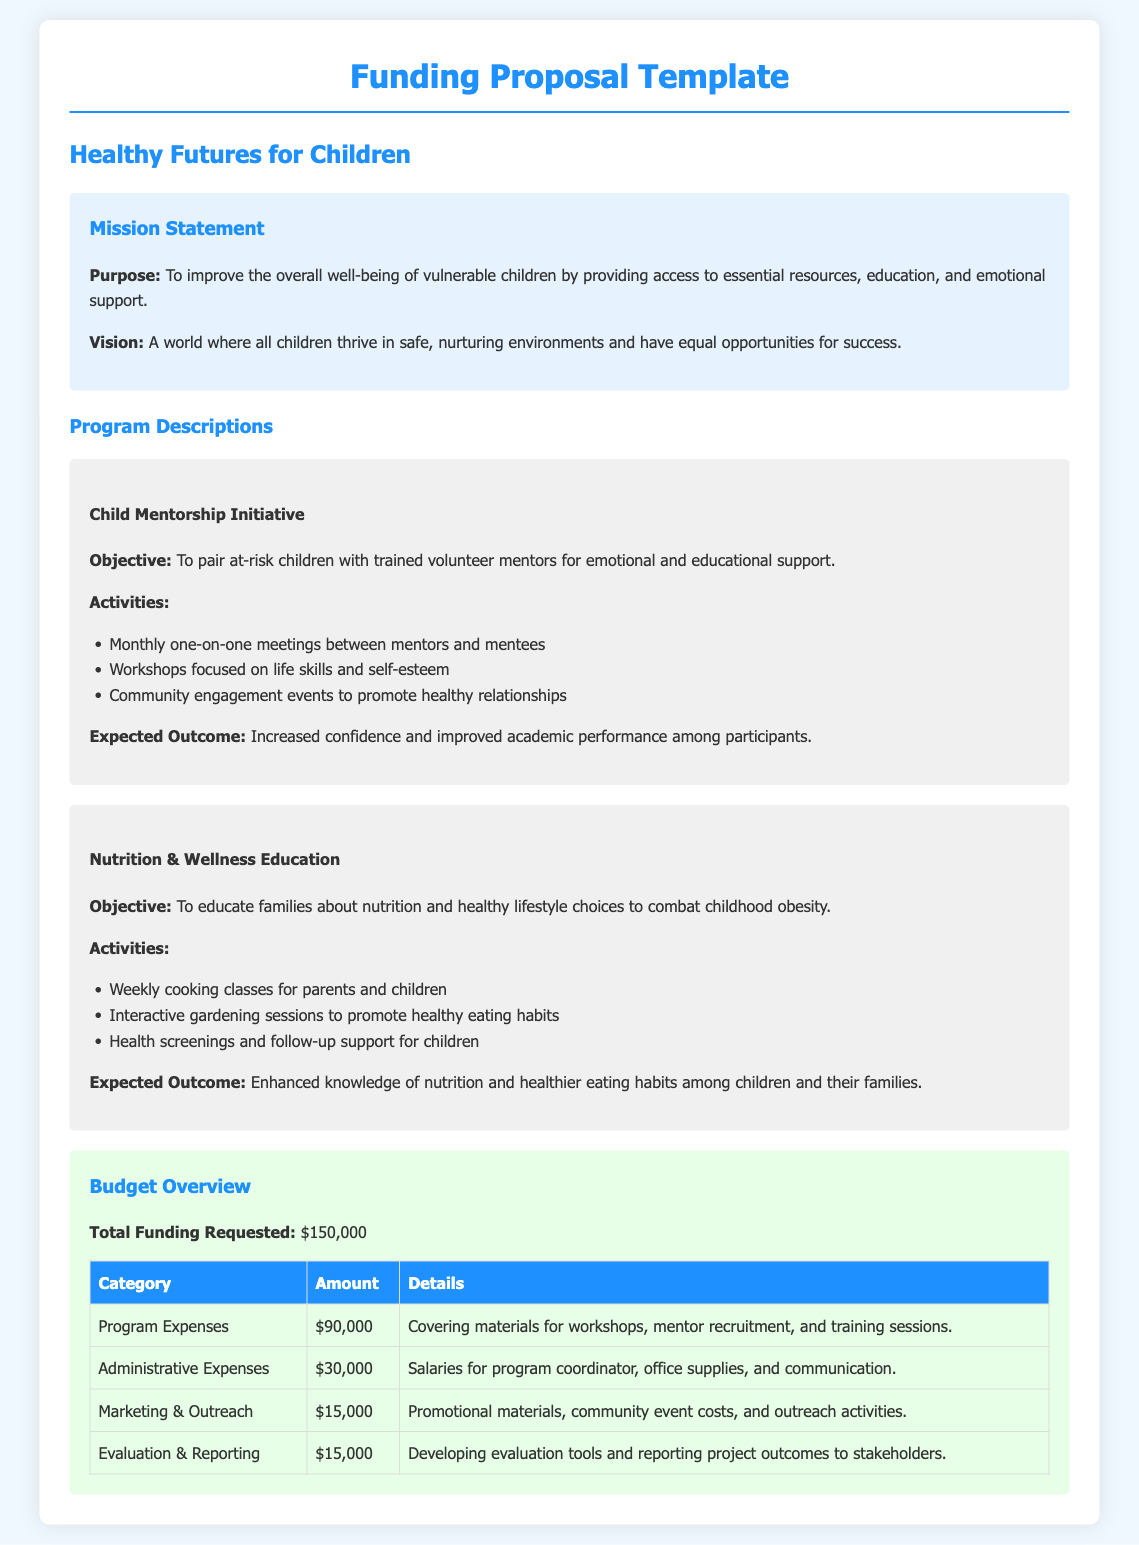What is the purpose of the nonprofit? The purpose is stated in the mission statement as improving the overall well-being of vulnerable children by providing access to essential resources, education, and emotional support.
Answer: To improve the overall well-being of vulnerable children What is the total funding requested? The total funding requested is clearly outlined in the budget overview section of the document.
Answer: $150,000 What program focuses on educating families about nutrition? Referring to the program descriptions, this program's objective is specified.
Answer: Nutrition & Wellness Education How much is allocated for program expenses? The budget overview provides specific amounts allocated for different expense categories including program expenses.
Answer: $90,000 What is the expected outcome of the Child Mentorship Initiative? The expected outcome is detailed in the program description section for this initiative.
Answer: Increased confidence and improved academic performance What is the vision of the nonprofit organization? The vision is stated in the mission statement and reflects the organization's aspirations for children's futures.
Answer: A world where all children thrive in safe, nurturing environments What activities are included in the Nutrition & Wellness Education program? The document lists specific activities under this program's description that support its objective.
Answer: Weekly cooking classes, interactive gardening sessions, health screenings How much is budgeted for marketing and outreach? This information is presented in the budget overview, specifically under the marketing & outreach category.
Answer: $15,000 